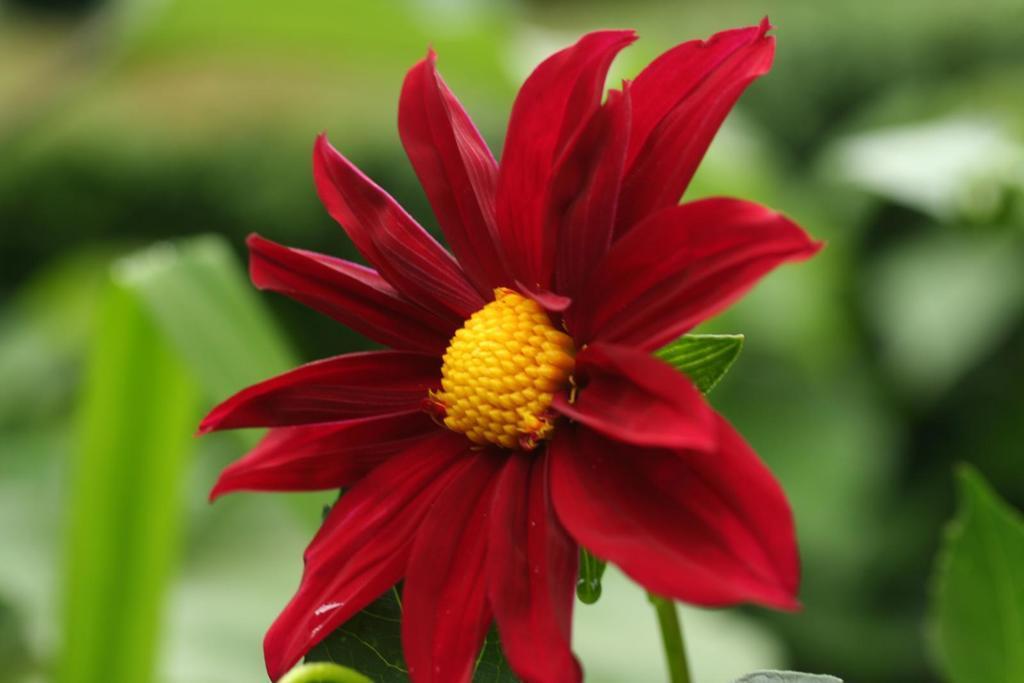Describe this image in one or two sentences. In the center of the image there is a flower which is in red color and there are leaves. 